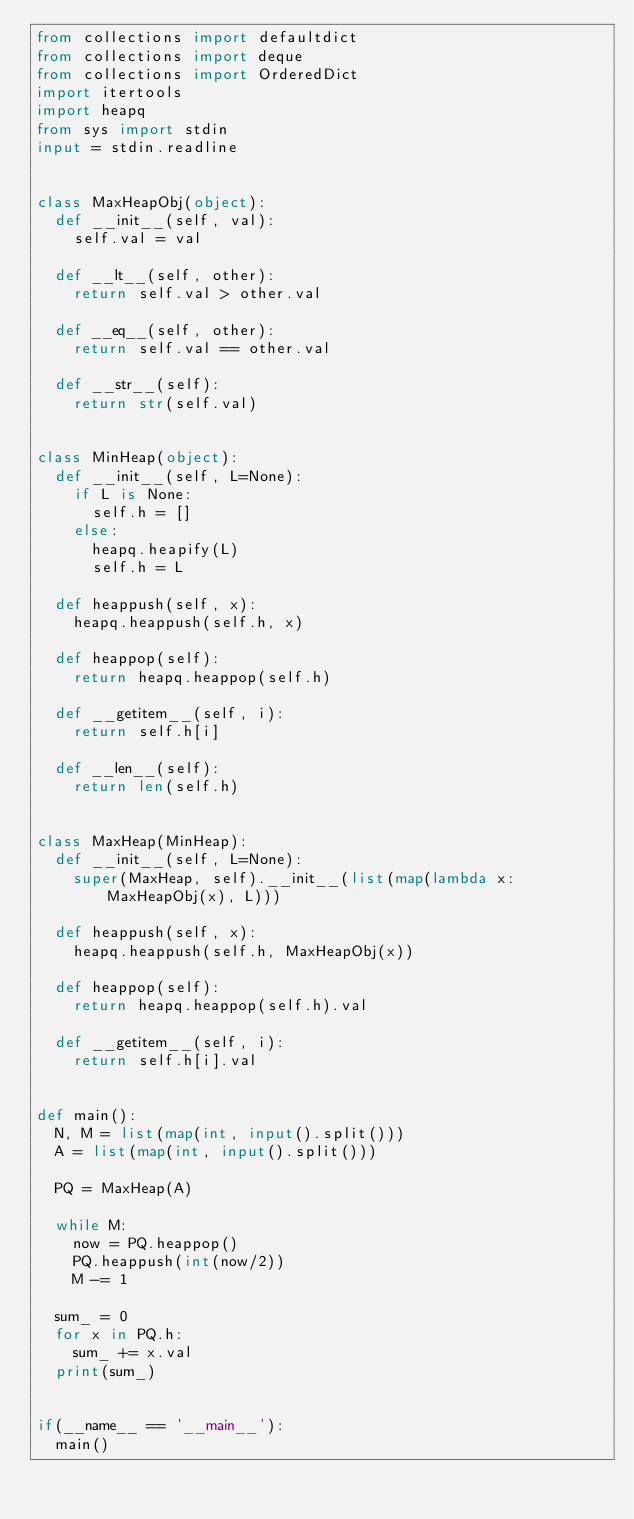<code> <loc_0><loc_0><loc_500><loc_500><_Python_>from collections import defaultdict
from collections import deque
from collections import OrderedDict
import itertools
import heapq
from sys import stdin
input = stdin.readline


class MaxHeapObj(object):
  def __init__(self, val):
    self.val = val

  def __lt__(self, other):
    return self.val > other.val

  def __eq__(self, other):
    return self.val == other.val

  def __str__(self):
    return str(self.val)


class MinHeap(object):
  def __init__(self, L=None):
    if L is None:
      self.h = []
    else:
      heapq.heapify(L)
      self.h = L

  def heappush(self, x):
    heapq.heappush(self.h, x)

  def heappop(self):
    return heapq.heappop(self.h)

  def __getitem__(self, i):
    return self.h[i]

  def __len__(self):
    return len(self.h)


class MaxHeap(MinHeap):
  def __init__(self, L=None):
    super(MaxHeap, self).__init__(list(map(lambda x: MaxHeapObj(x), L)))

  def heappush(self, x):
    heapq.heappush(self.h, MaxHeapObj(x))

  def heappop(self):
    return heapq.heappop(self.h).val

  def __getitem__(self, i):
    return self.h[i].val


def main():
  N, M = list(map(int, input().split()))
  A = list(map(int, input().split()))

  PQ = MaxHeap(A)

  while M:
    now = PQ.heappop()
    PQ.heappush(int(now/2))
    M -= 1

  sum_ = 0
  for x in PQ.h:
    sum_ += x.val
  print(sum_)


if(__name__ == '__main__'):
  main()
</code> 